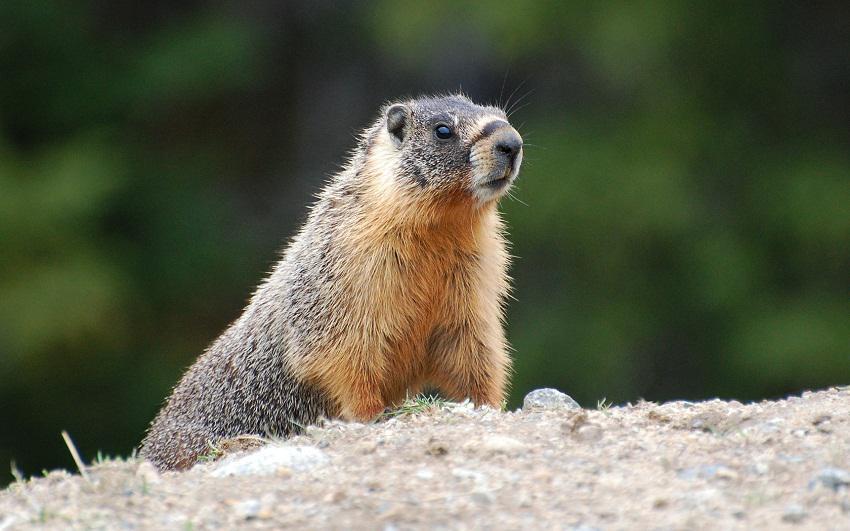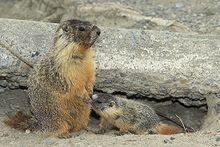The first image is the image on the left, the second image is the image on the right. Examine the images to the left and right. Is the description "There is at least one ground hog with its front paws resting on a rock." accurate? Answer yes or no. No. The first image is the image on the left, the second image is the image on the right. Assess this claim about the two images: "An image shows a marmot standing upright, with its front paws hanging downward.". Correct or not? Answer yes or no. Yes. 